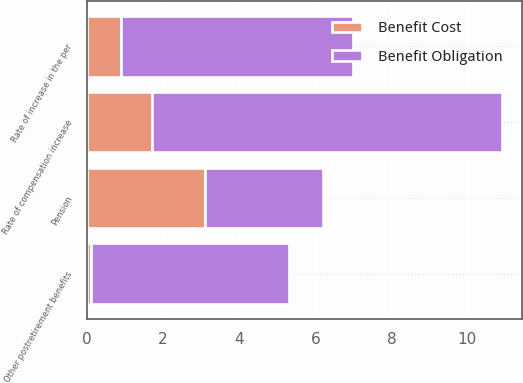Convert chart to OTSL. <chart><loc_0><loc_0><loc_500><loc_500><stacked_bar_chart><ecel><fcel>Pension<fcel>Other postretirement benefits<fcel>Rate of compensation increase<fcel>Rate of increase in the per<nl><fcel>Benefit Obligation<fcel>3.1<fcel>5.2<fcel>9.2<fcel>6.1<nl><fcel>Benefit Cost<fcel>3.1<fcel>0.1<fcel>1.7<fcel>0.9<nl></chart> 